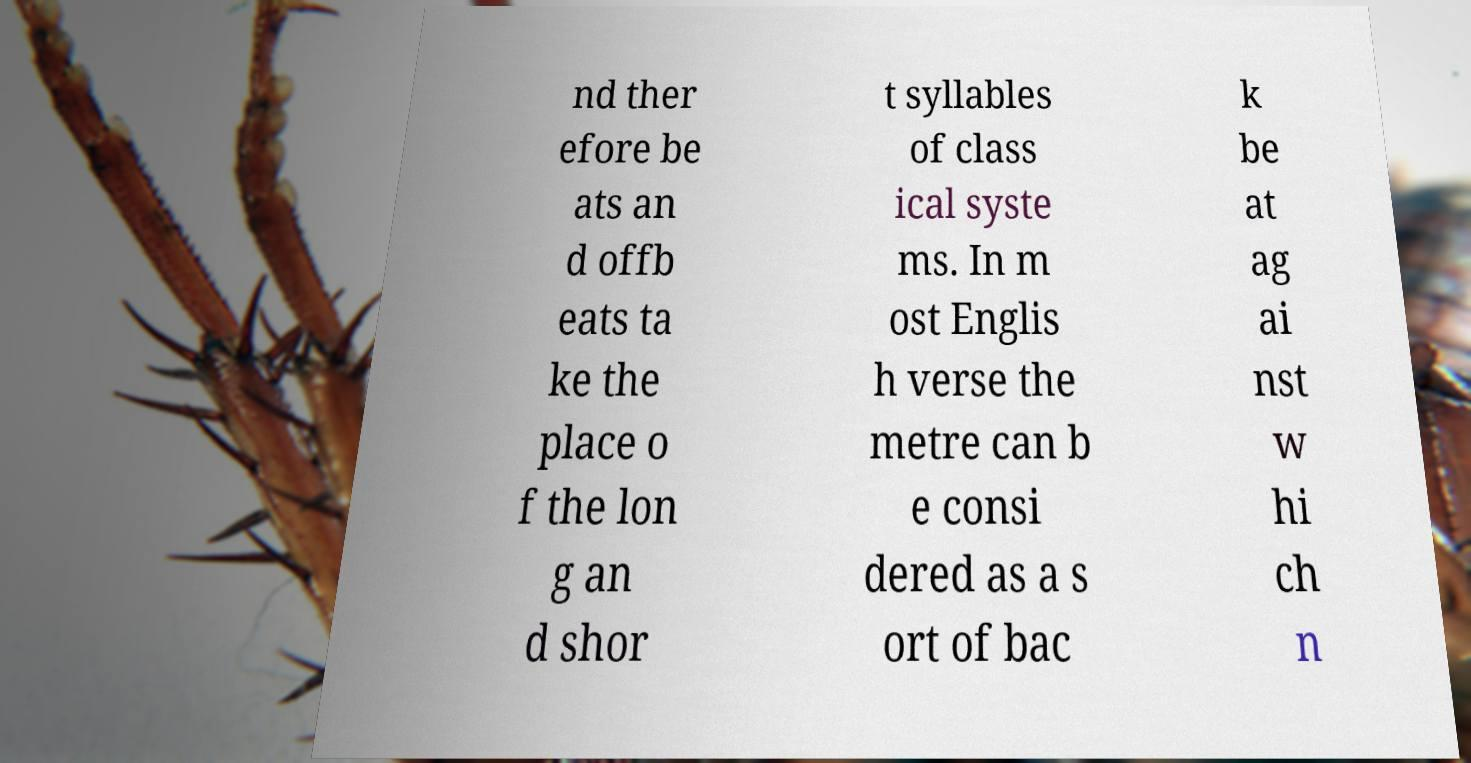Could you extract and type out the text from this image? nd ther efore be ats an d offb eats ta ke the place o f the lon g an d shor t syllables of class ical syste ms. In m ost Englis h verse the metre can b e consi dered as a s ort of bac k be at ag ai nst w hi ch n 